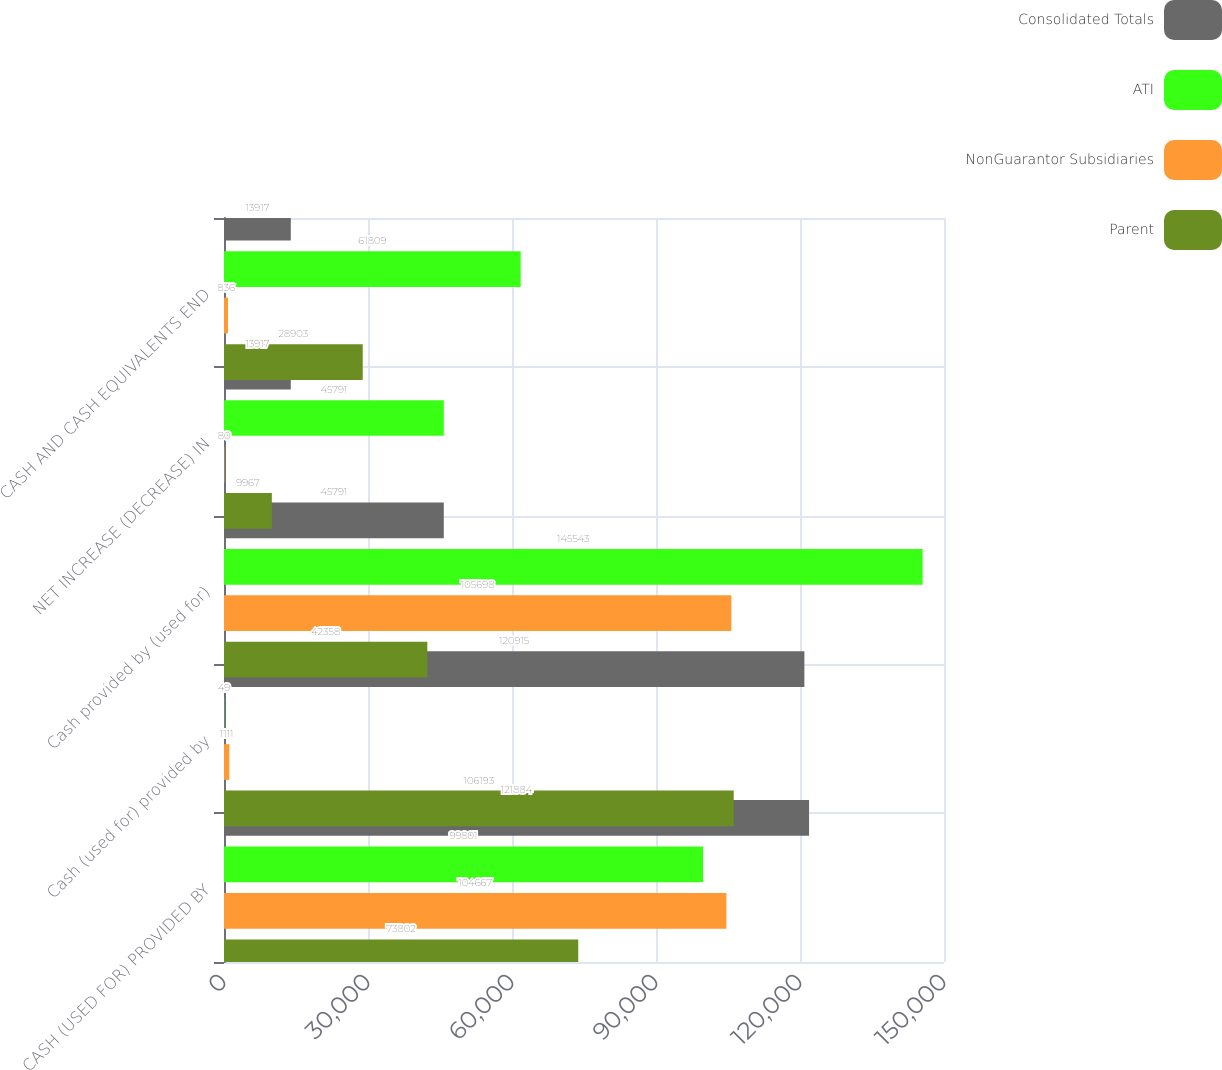Convert chart to OTSL. <chart><loc_0><loc_0><loc_500><loc_500><stacked_bar_chart><ecel><fcel>CASH (USED FOR) PROVIDED BY<fcel>Cash (used for) provided by<fcel>Cash provided by (used for)<fcel>NET INCREASE (DECREASE) IN<fcel>CASH AND CASH EQUIVALENTS END<nl><fcel>Consolidated Totals<fcel>121884<fcel>120915<fcel>45791<fcel>13917<fcel>13917<nl><fcel>ATI<fcel>99801<fcel>49<fcel>145543<fcel>45791<fcel>61809<nl><fcel>NonGuarantor Subsidiaries<fcel>104667<fcel>1111<fcel>105698<fcel>80<fcel>836<nl><fcel>Parent<fcel>73802<fcel>106193<fcel>42358<fcel>9967<fcel>28903<nl></chart> 